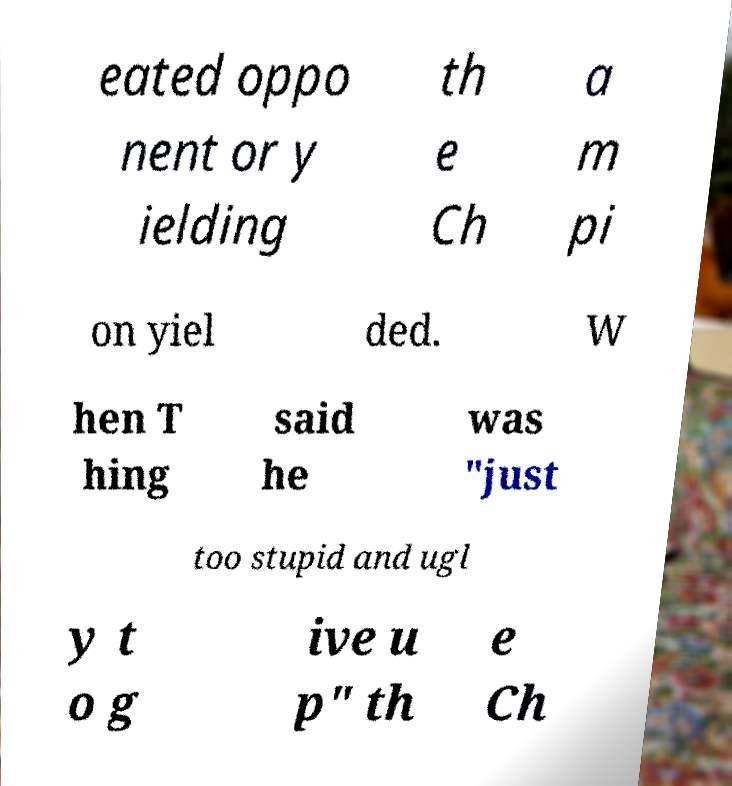I need the written content from this picture converted into text. Can you do that? eated oppo nent or y ielding th e Ch a m pi on yiel ded. W hen T hing said he was "just too stupid and ugl y t o g ive u p" th e Ch 